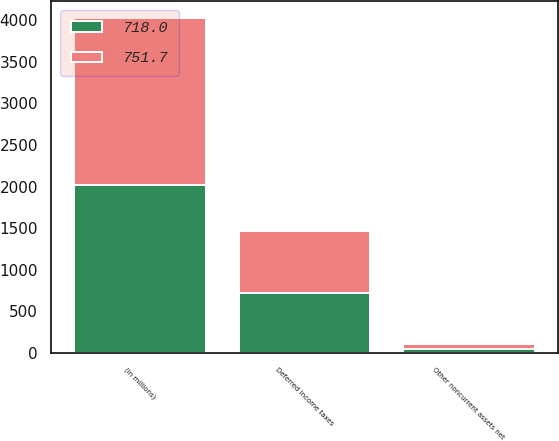Convert chart. <chart><loc_0><loc_0><loc_500><loc_500><stacked_bar_chart><ecel><fcel>(in millions)<fcel>Other noncurrent assets net<fcel>Deferred income taxes<nl><fcel>718<fcel>2017<fcel>43.8<fcel>718<nl><fcel>751.7<fcel>2016<fcel>61.7<fcel>751.7<nl></chart> 